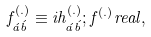Convert formula to latex. <formula><loc_0><loc_0><loc_500><loc_500>f _ { \acute { a } \acute { b } } ^ { ( . ) } \equiv i h _ { \acute { a } \acute { b } } ^ { ( . ) } ; f ^ { ( . ) } r e a l ,</formula> 